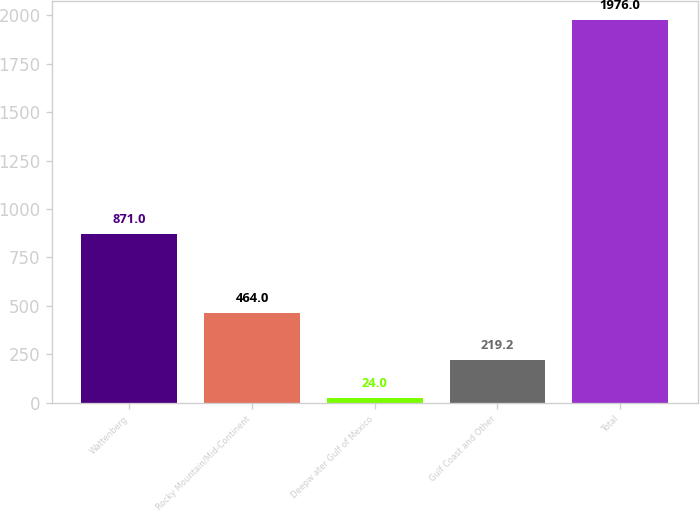<chart> <loc_0><loc_0><loc_500><loc_500><bar_chart><fcel>Wattenberg<fcel>Rocky Mountain/Mid-Continent<fcel>Deepw ater Gulf of Mexico<fcel>Gulf Coast and Other<fcel>Total<nl><fcel>871<fcel>464<fcel>24<fcel>219.2<fcel>1976<nl></chart> 